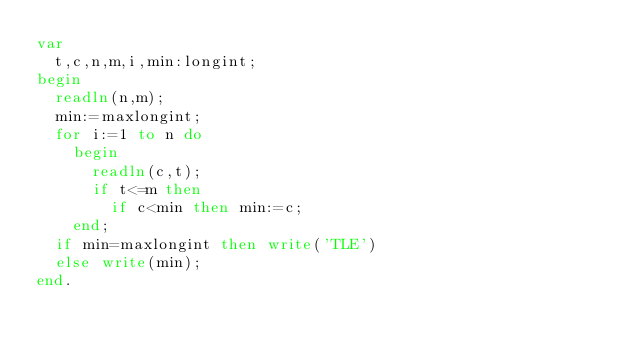Convert code to text. <code><loc_0><loc_0><loc_500><loc_500><_Pascal_>var
  t,c,n,m,i,min:longint;
begin
  readln(n,m);
  min:=maxlongint;
  for i:=1 to n do
    begin
	  readln(c,t);
	  if t<=m then 
	    if c<min then min:=c;
	end;
  if min=maxlongint then write('TLE')
  else write(min);
end.</code> 